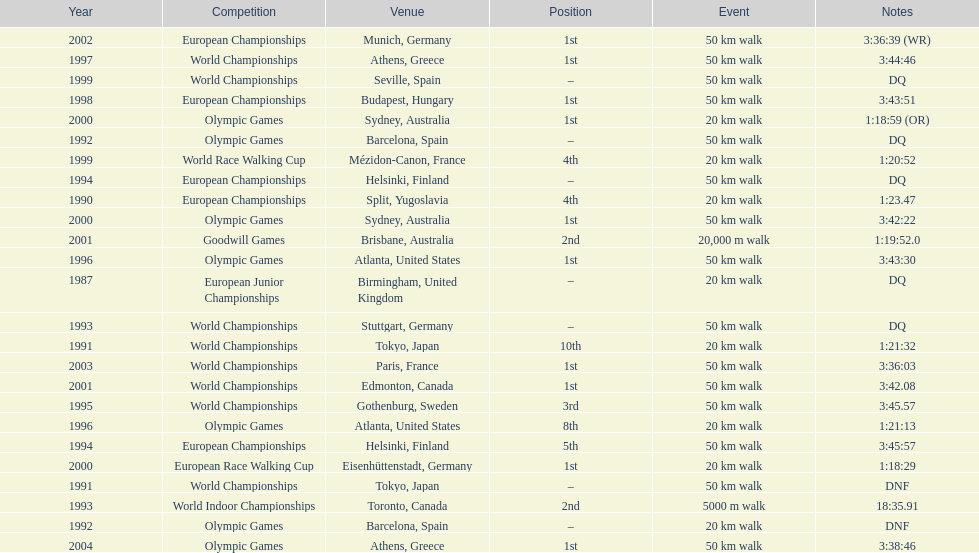What was the difference between korzeniowski's performance at the 1996 olympic games and the 2000 olympic games in the 20 km walk? 2:14. 